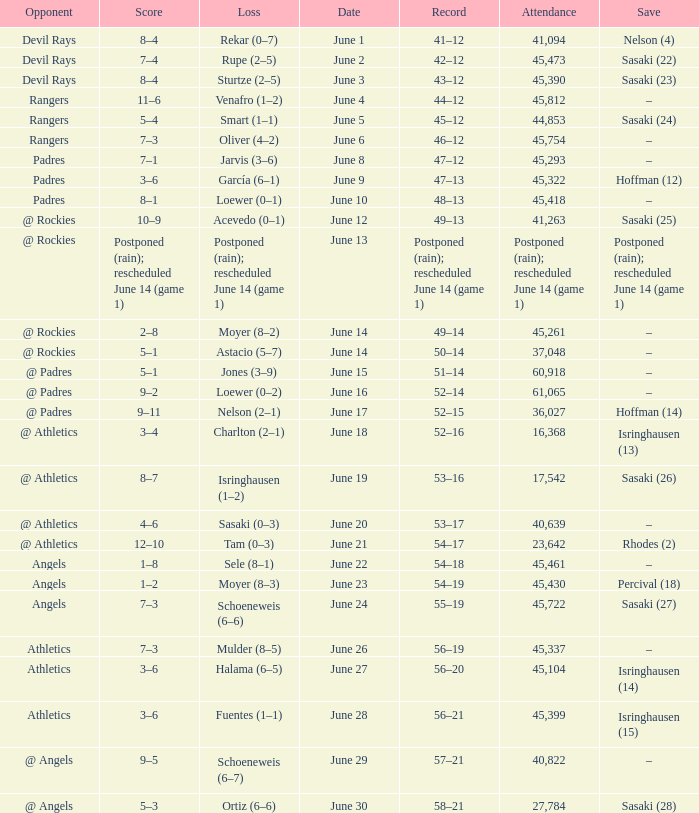What was the date of the Mariners game when they had a record of 53–17? June 20. 